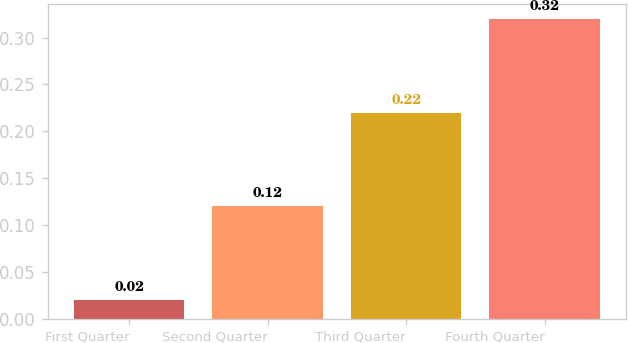<chart> <loc_0><loc_0><loc_500><loc_500><bar_chart><fcel>First Quarter<fcel>Second Quarter<fcel>Third Quarter<fcel>Fourth Quarter<nl><fcel>0.02<fcel>0.12<fcel>0.22<fcel>0.32<nl></chart> 